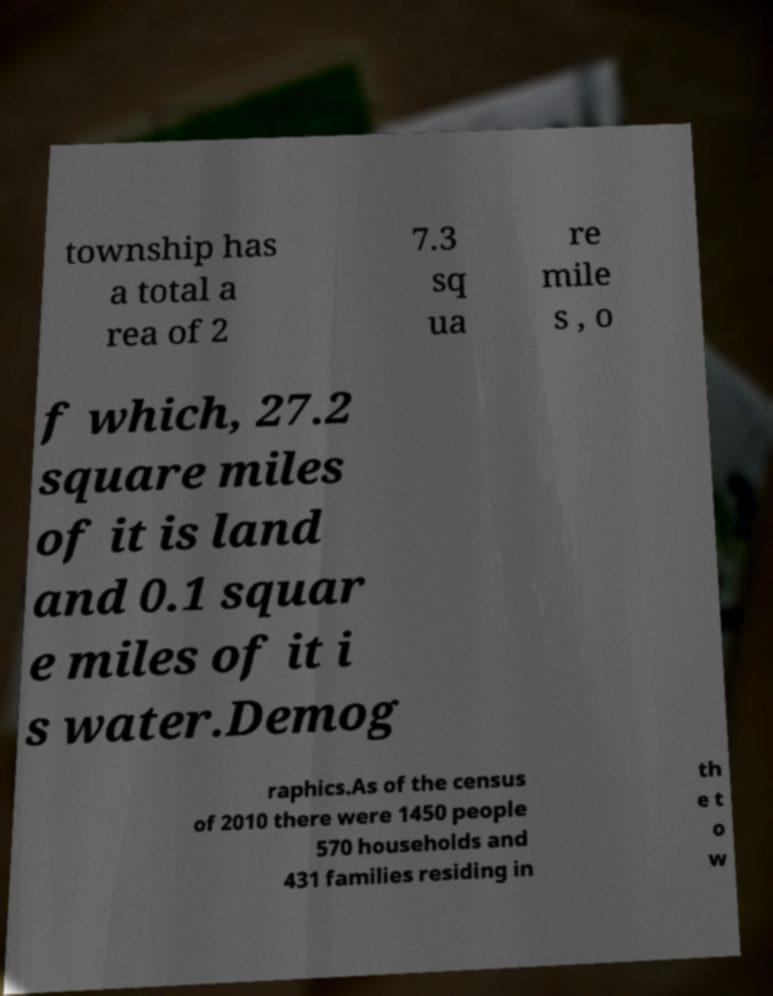Can you accurately transcribe the text from the provided image for me? township has a total a rea of 2 7.3 sq ua re mile s , o f which, 27.2 square miles of it is land and 0.1 squar e miles of it i s water.Demog raphics.As of the census of 2010 there were 1450 people 570 households and 431 families residing in th e t o w 